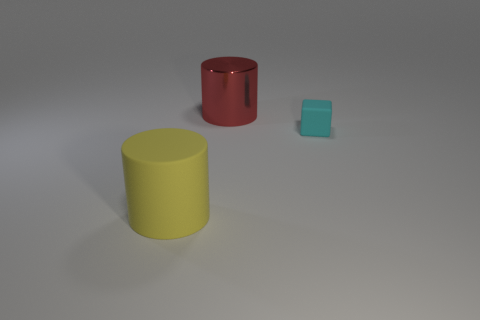What colors are the cylinders in the image? The colors of the cylinders in the image are red and yellow. The red cylinder has a shiny surface, while the yellow one has a matte finish. 